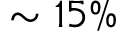Convert formula to latex. <formula><loc_0><loc_0><loc_500><loc_500>\sim 1 5 \%</formula> 